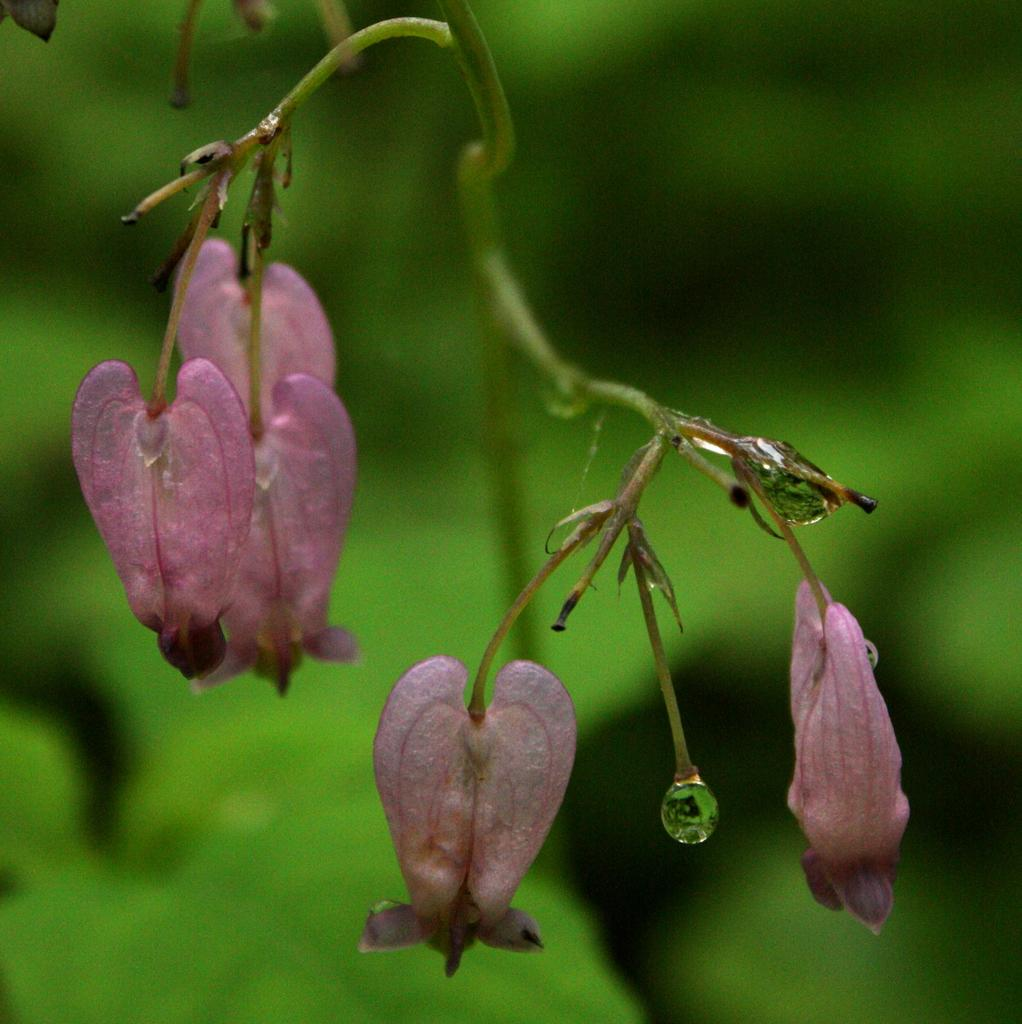What type of plants are visible in the image? There are flowers in the image. What part of the flowers can be seen in the image? There are stems in the image. What colors are present in the background of the image? The background of the image is blue and green. What statement is being made by the wind in the image? There is no wind present in the image, and therefore no statement can be made by it. 